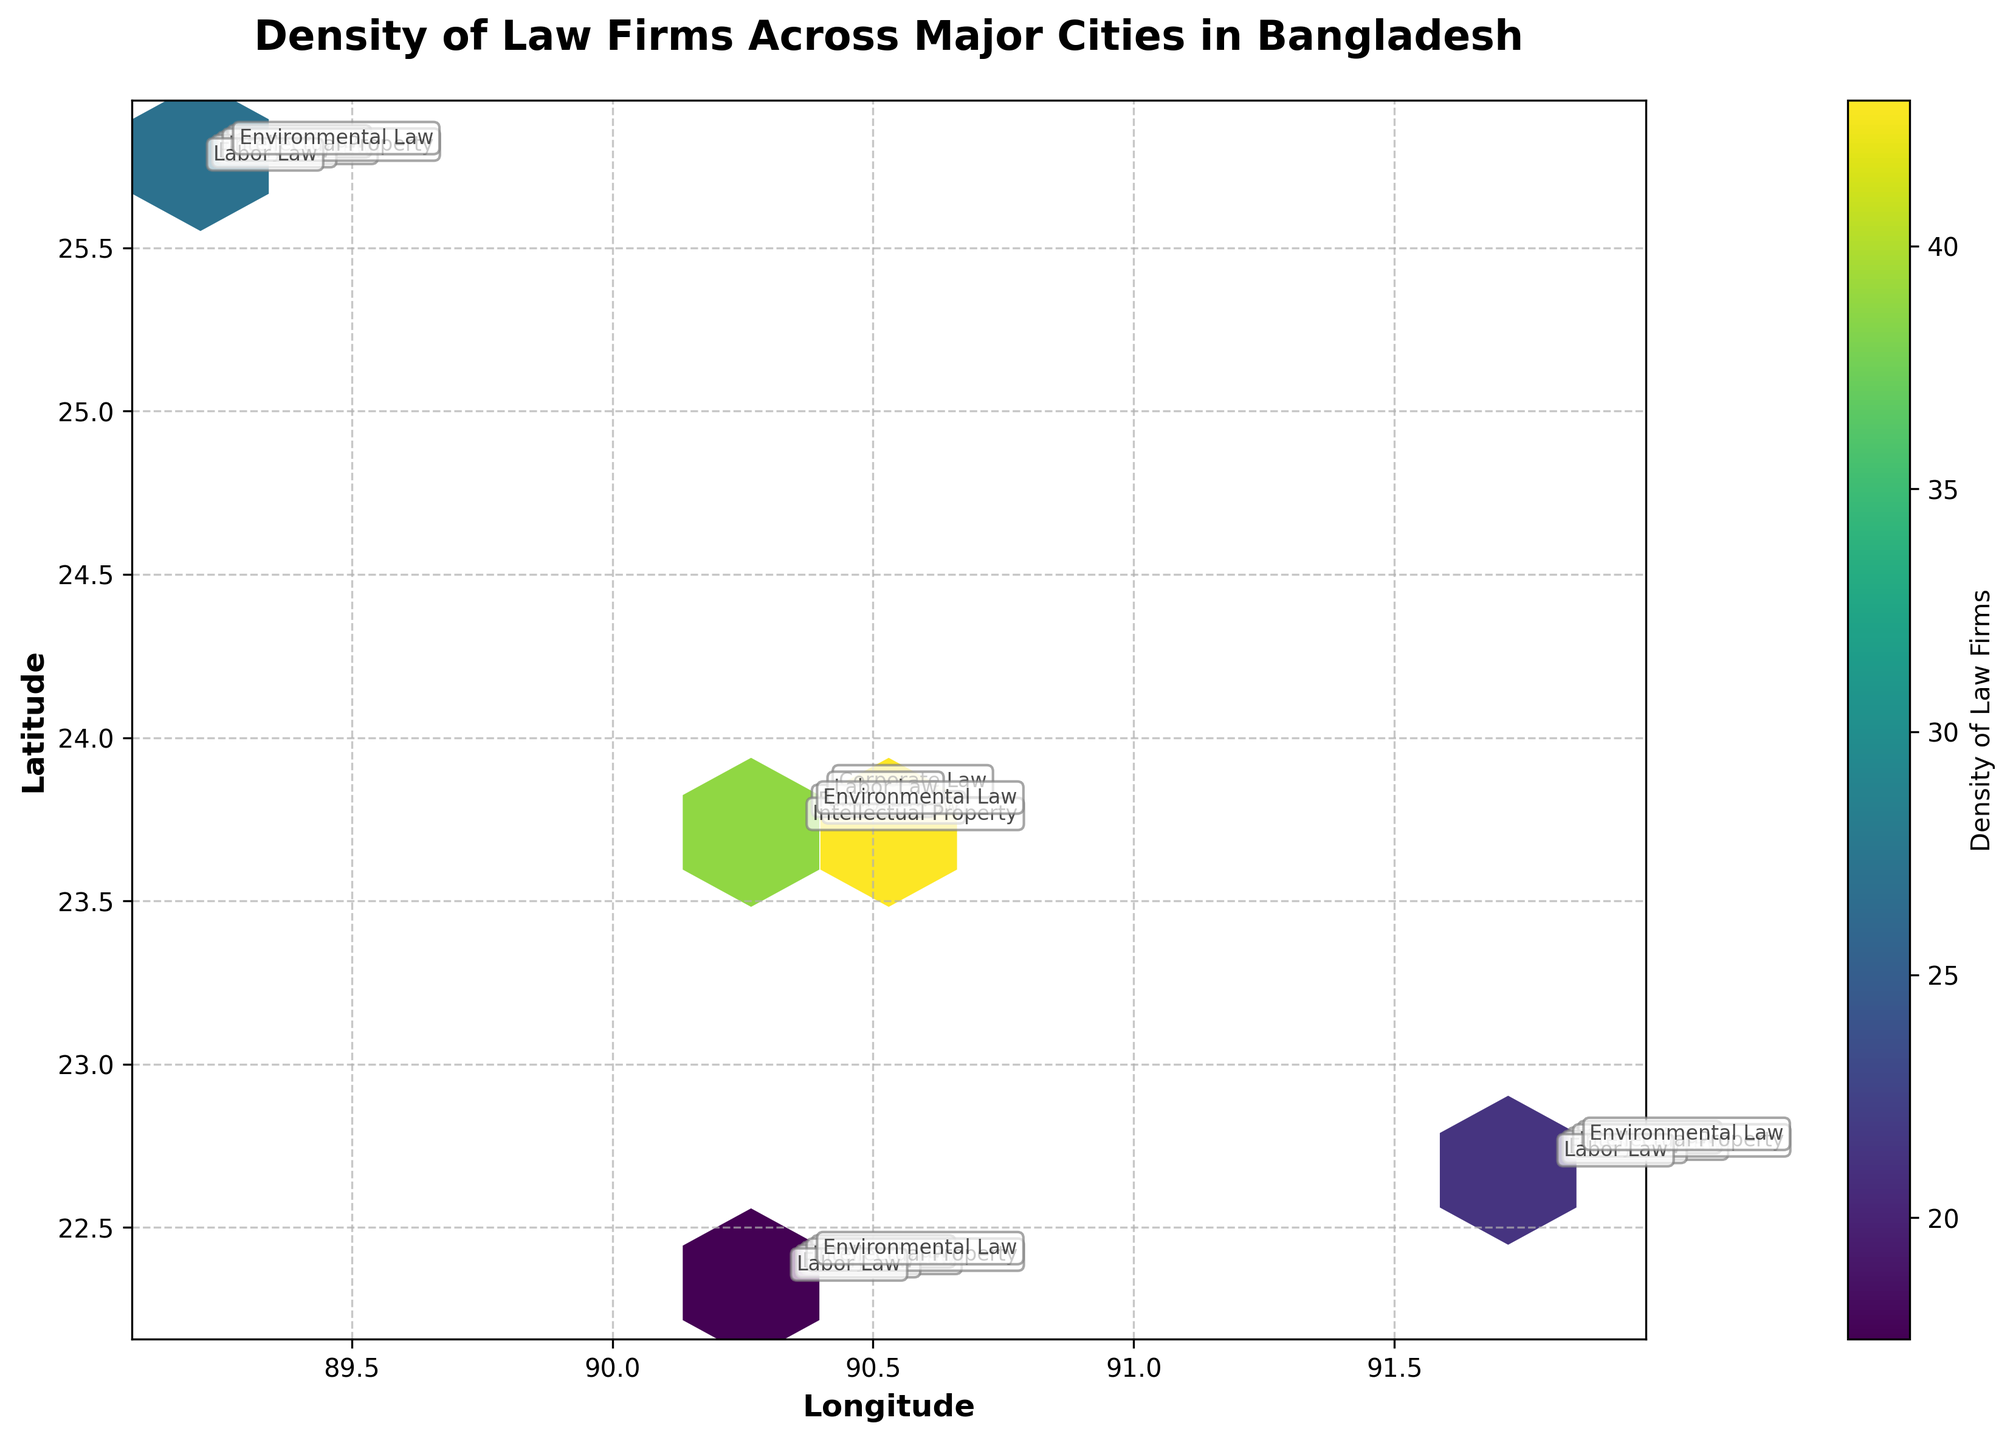What is the title of the plot? The title is located at the top of the plot. It reads "Density of Law Firms Across Major Cities in Bangladesh".
Answer: Density of Law Firms Across Major Cities in Bangladesh What does the color gradient in the hexagons represent? The color gradient, indicated by the color bar on the side, represents the density of law firms. Different colors correspond to different density levels.
Answer: Density of law firms Which axis represents the latitude? The y-axis represents the latitude. It is labeled "Latitude" on the axis.
Answer: Y-axis How many data points are associated with Dhaka (approximately at coordinates 90.40, 23.79)? To find this, look at the hexagon located around coordinates 90.40 (Longitude) and 23.79 (Latitude) and check the associated color on the color bar. The exact density value isn't displayed but we can use the color bar to roughly estimate it. Let's approximate it to around 41 based on the color.
Answer: Approximately 41 Which city has the highest density of law firms based on the plot? Looking at the plot, find the darkest hexagon (which corresponds to the highest density). This hexagon is located near coordinates (90.37, 23.75), which is Dhaka.
Answer: Dhaka What specialization area has the highest density of law firms in Dhaka? Identify the highest density hexagon in Dhaka and read the annotation for specialization closest to it. The law firm type in this densest area is "Family Law".
Answer: Family Law Compare the density of law firms specializing in Corporate Law between Dhaka (90.41, 23.81) and Chittagong (91.82, 22.70). Which city has a higher density? Find the hexagon near Dhaka (90.41, 23.81) for Corporate Law specialization and compare it to the hexagon in Chittagong (91.82, 22.70). The color indicates that Dhaka has a density of 45 while Chittagong has a density of 28. Therefore, Dhaka has a higher density.
Answer: Dhaka Considering all data points, what is the average density of law firms specializing in Environmental Law? Environmental Law densities are 35 (Dhaka), 15 (Chittagong), 18 (another city), and 12 (another city). Summing these gives 35+15+18+12=80, divide by 4 to get the average density, which is 80/4 = 20.
Answer: 20 Which specialization has the least representation in Chittagong (approx. coordinates 91.80-91.85, 22.68-22.73)? Examine the specializations around Chittagong's coordinates. The least density value indicated in Chittagong is for Environmental Law with a density of 15.
Answer: Environmental Law 